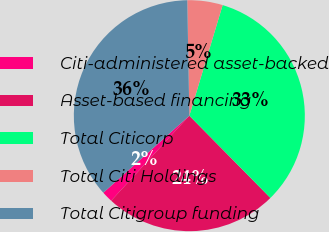Convert chart to OTSL. <chart><loc_0><loc_0><loc_500><loc_500><pie_chart><fcel>Citi-administered asset-backed<fcel>Asset-based financing<fcel>Total Citicorp<fcel>Total Citi Holdings<fcel>Total Citigroup funding<nl><fcel>1.55%<fcel>24.21%<fcel>32.96%<fcel>4.94%<fcel>36.34%<nl></chart> 